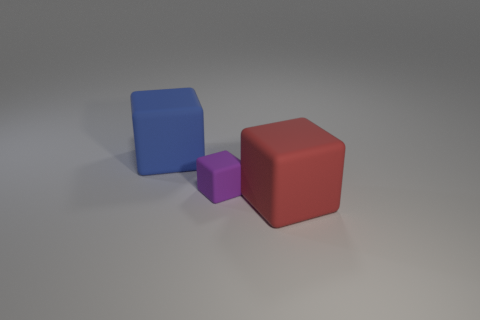Add 2 brown cubes. How many objects exist? 5 Add 1 purple things. How many purple things exist? 2 Subtract 0 yellow cylinders. How many objects are left? 3 Subtract all red matte blocks. Subtract all big shiny things. How many objects are left? 2 Add 1 big red rubber objects. How many big red rubber objects are left? 2 